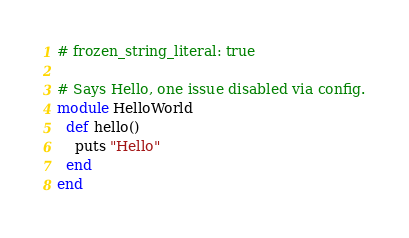<code> <loc_0><loc_0><loc_500><loc_500><_Ruby_># frozen_string_literal: true

# Says Hello, one issue disabled via config.
module HelloWorld
  def hello()
    puts "Hello"
  end
end
</code> 